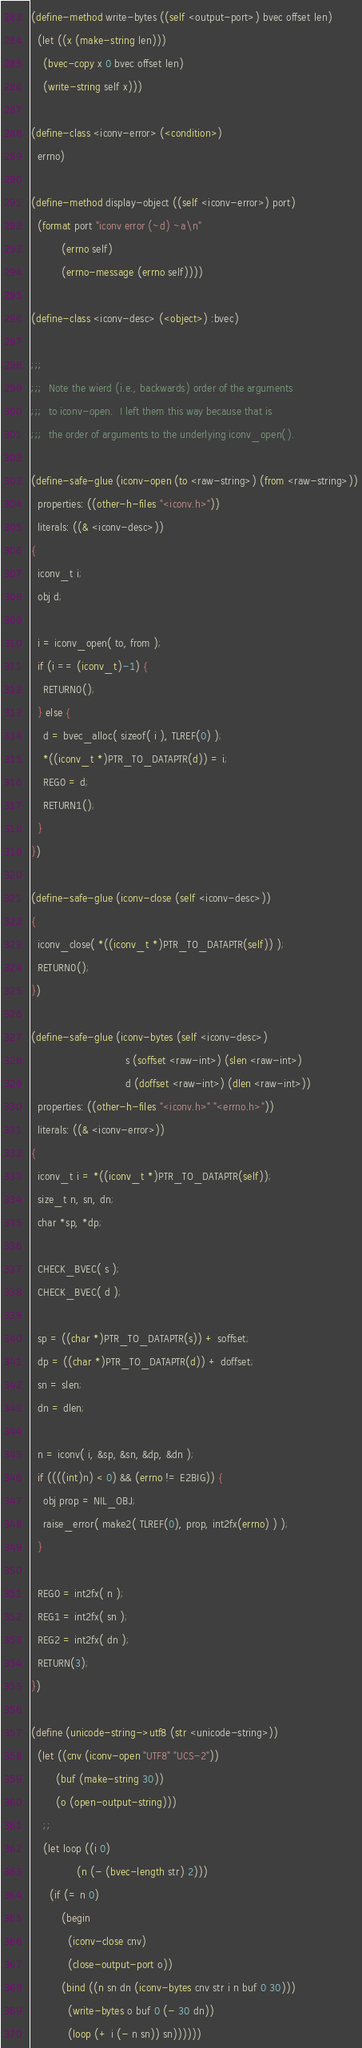Convert code to text. <code><loc_0><loc_0><loc_500><loc_500><_Scheme_>

(define-method write-bytes ((self <output-port>) bvec offset len)
  (let ((x (make-string len)))
    (bvec-copy x 0 bvec offset len)
    (write-string self x)))

(define-class <iconv-error> (<condition>)
  errno)

(define-method display-object ((self <iconv-error>) port)
  (format port "iconv error (~d) ~a\n"
          (errno self)
          (errno-message (errno self))))

(define-class <iconv-desc> (<object>) :bvec)

;;;
;;;  Note the wierd (i.e., backwards) order of the arguments
;;;  to iconv-open.  I left them this way because that is
;;;  the order of arguments to the underlying iconv_open().

(define-safe-glue (iconv-open (to <raw-string>) (from <raw-string>))
  properties: ((other-h-files "<iconv.h>"))
  literals: ((& <iconv-desc>))
{
  iconv_t i;
  obj d;

  i = iconv_open( to, from );
  if (i == (iconv_t)-1) {
    RETURN0();
  } else {
    d = bvec_alloc( sizeof( i ), TLREF(0) );
    *((iconv_t *)PTR_TO_DATAPTR(d)) = i;
    REG0 = d;
    RETURN1();
  }
})

(define-safe-glue (iconv-close (self <iconv-desc>))
{
  iconv_close( *((iconv_t *)PTR_TO_DATAPTR(self)) );
  RETURN0();
})

(define-safe-glue (iconv-bytes (self <iconv-desc>) 
                               s (soffset <raw-int>) (slen <raw-int>)
                               d (doffset <raw-int>) (dlen <raw-int>))
  properties: ((other-h-files "<iconv.h>" "<errno.h>"))
  literals: ((& <iconv-error>))
{
  iconv_t i = *((iconv_t *)PTR_TO_DATAPTR(self));
  size_t n, sn, dn;
  char *sp, *dp;

  CHECK_BVEC( s );
  CHECK_BVEC( d );

  sp = ((char *)PTR_TO_DATAPTR(s)) + soffset;
  dp = ((char *)PTR_TO_DATAPTR(d)) + doffset;
  sn = slen;
  dn = dlen;

  n = iconv( i, &sp, &sn, &dp, &dn );
  if ((((int)n) < 0) && (errno != E2BIG)) {
    obj prop = NIL_OBJ;
    raise_error( make2( TLREF(0), prop, int2fx(errno) ) );
  }

  REG0 = int2fx( n );
  REG1 = int2fx( sn );
  REG2 = int2fx( dn );
  RETURN(3);
})

(define (unicode-string->utf8 (str <unicode-string>))
  (let ((cnv (iconv-open "UTF8" "UCS-2"))
        (buf (make-string 30))
        (o (open-output-string)))
    ;;
    (let loop ((i 0)
               (n (- (bvec-length str) 2)))
      (if (= n 0)
          (begin
            (iconv-close cnv)
            (close-output-port o))
          (bind ((n sn dn (iconv-bytes cnv str i n buf 0 30)))
            (write-bytes o buf 0 (- 30 dn))
            (loop (+ i (- n sn)) sn))))))
</code> 